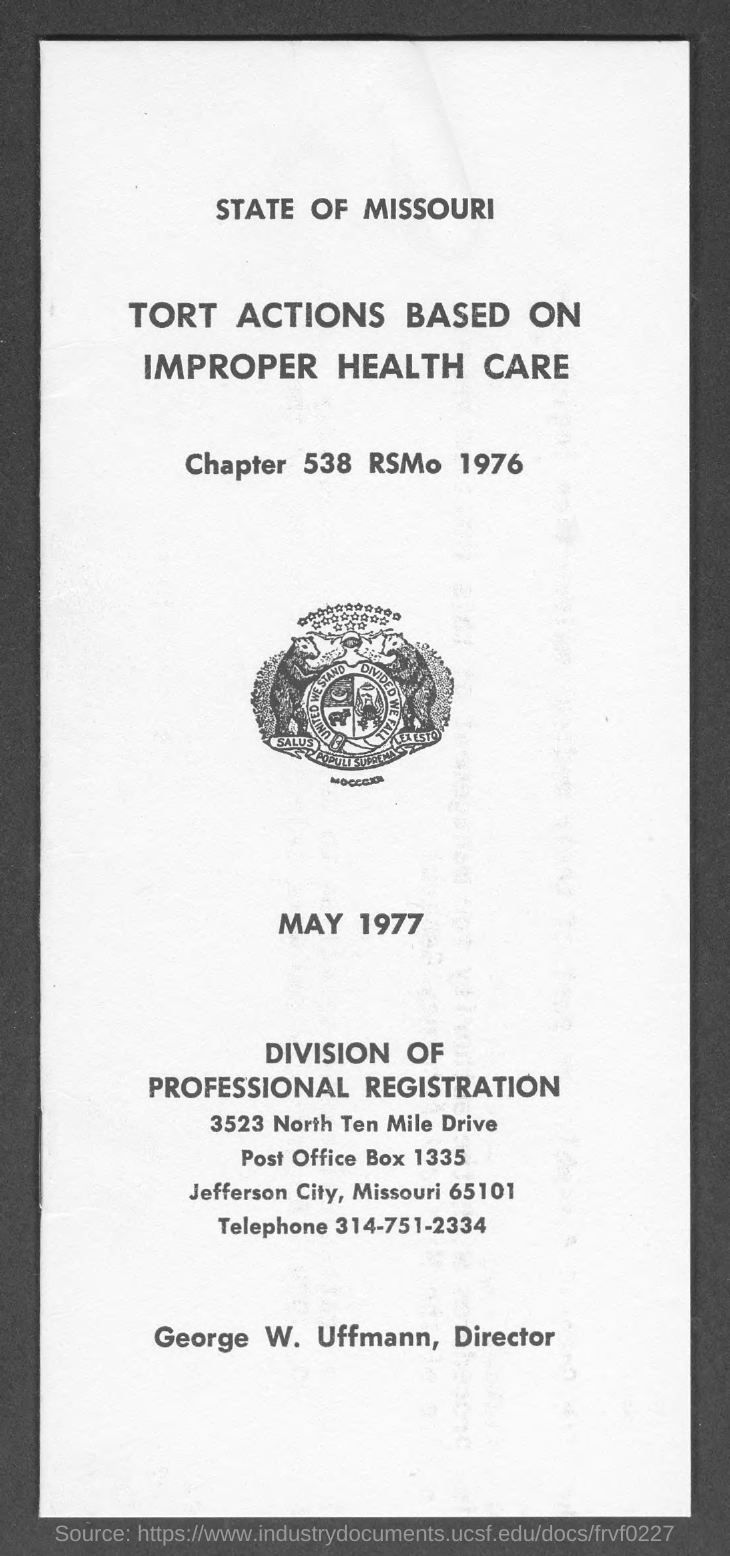What is the chapter no. mentioned in the given page ?
Your response must be concise. 538. What is the rsmo no. mentioned in the given page ?
Your response must be concise. 1976. What is the heading mentioned in the given page ?
Your response must be concise. Tort actions based on improper health care. What is the post office box no. mentioned in the given page ?
Your answer should be compact. 1335. What is the name of the city mentioned in the given page ?
Make the answer very short. JEFFERSON CITY. What is the telephone no. mentioned in the given page ?
Provide a succinct answer. 314-751-2334. What is the name of the director mentioned in the given page ?
Keep it short and to the point. George w. uffmann. What is the date mentioned in the given page ?
Your answer should be very brief. May 1977. 